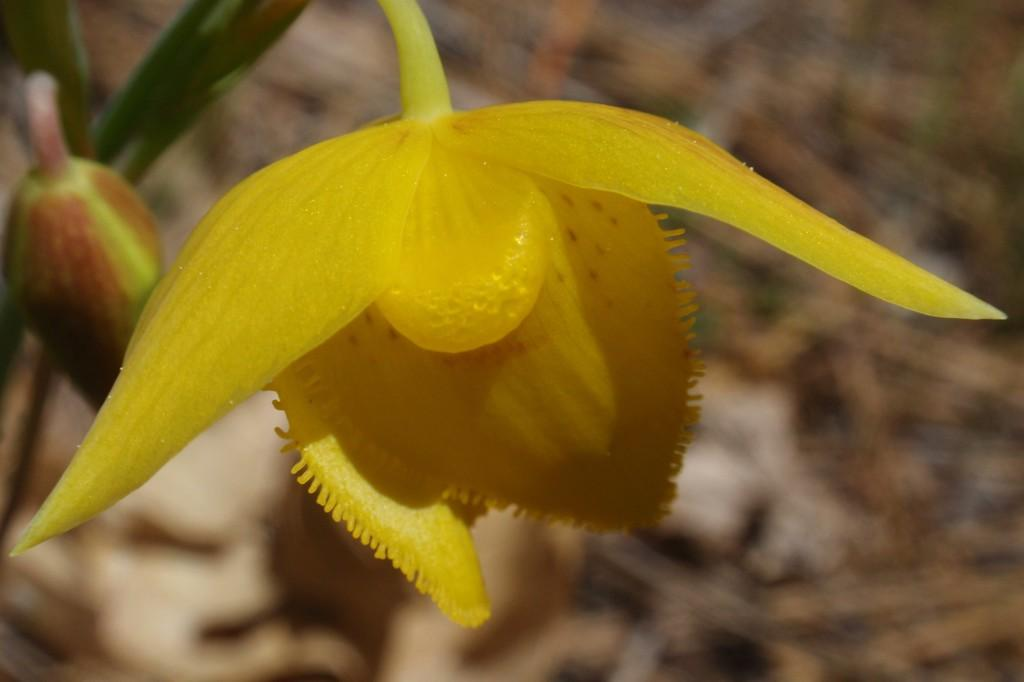What type of plant can be seen in the image? There is a flower in the image. Can you describe the stage of development of the plant? There is a bud in the image. What else is present in the image besides the plant? There is an object in the image. How would you describe the background of the image? The background of the image is blurred. What type of tin is being used to hold the slave in the image? There is no tin or slave present in the image. The image features a flower, a bud, an object, and a blurred background. 